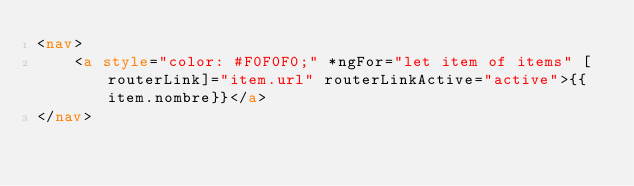Convert code to text. <code><loc_0><loc_0><loc_500><loc_500><_HTML_><nav>
    <a style="color: #F0F0F0;" *ngFor="let item of items" [routerLink]="item.url" routerLinkActive="active">{{item.nombre}}</a>
</nav></code> 